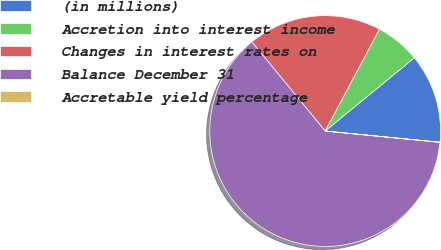<chart> <loc_0><loc_0><loc_500><loc_500><pie_chart><fcel>(in millions)<fcel>Accretion into interest income<fcel>Changes in interest rates on<fcel>Balance December 31<fcel>Accretable yield percentage<nl><fcel>12.5%<fcel>6.26%<fcel>18.75%<fcel>62.48%<fcel>0.01%<nl></chart> 